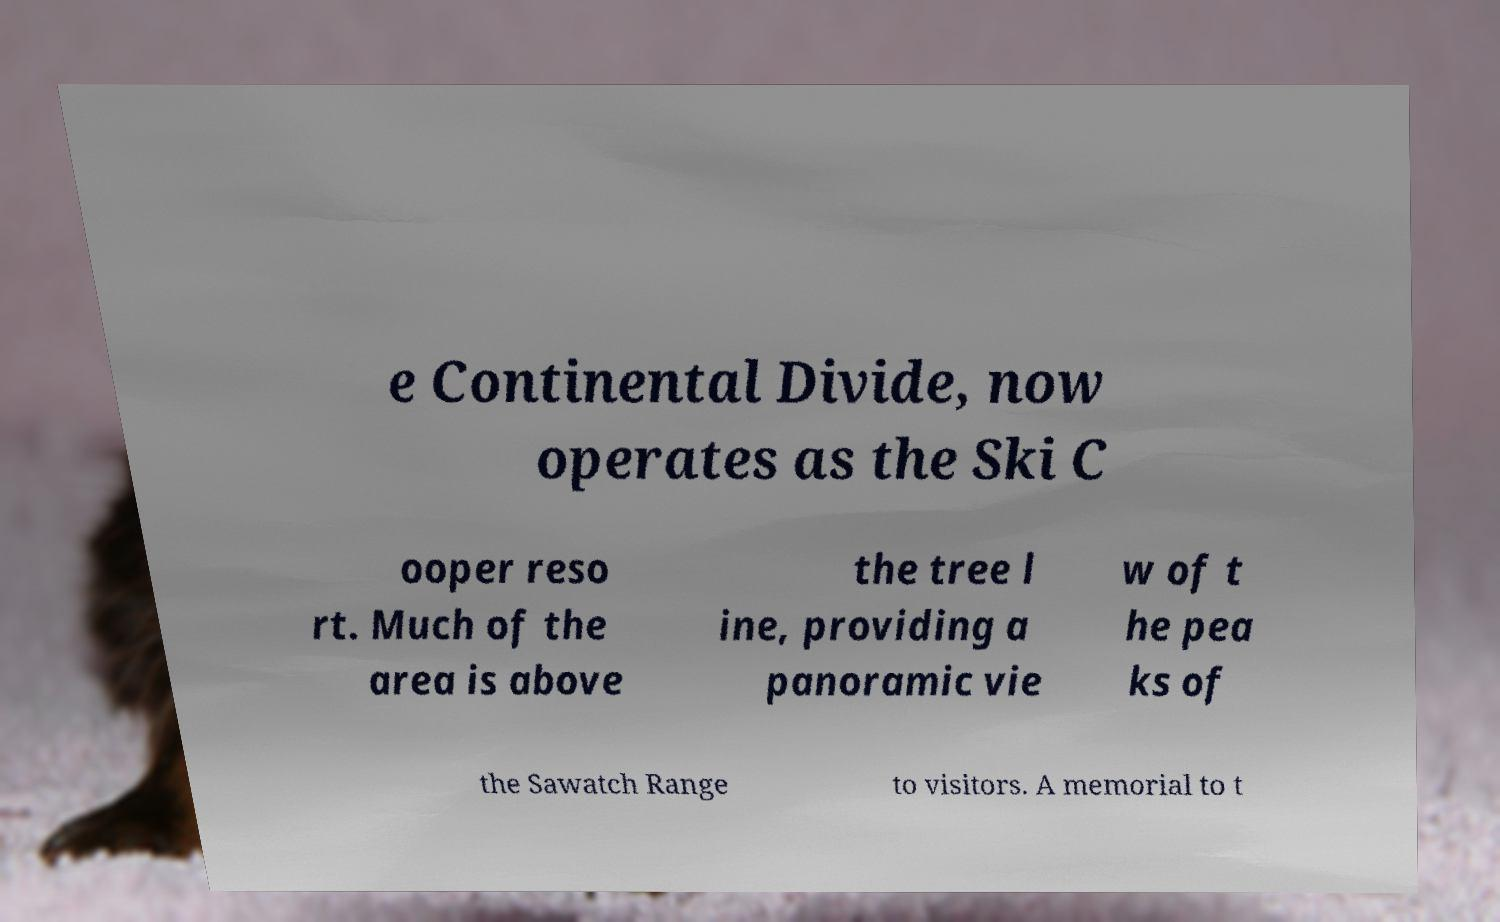Please identify and transcribe the text found in this image. e Continental Divide, now operates as the Ski C ooper reso rt. Much of the area is above the tree l ine, providing a panoramic vie w of t he pea ks of the Sawatch Range to visitors. A memorial to t 